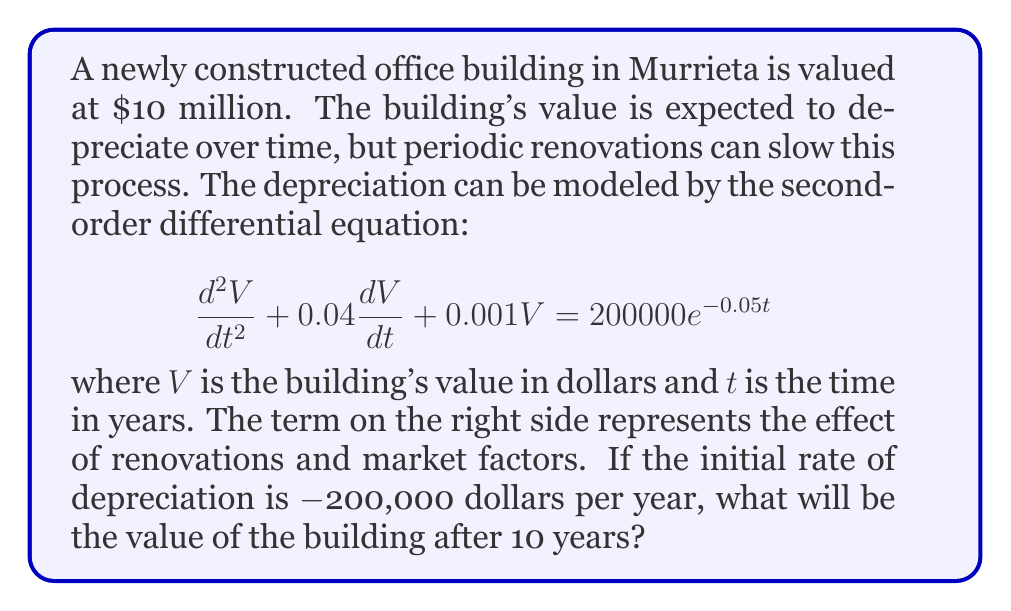Provide a solution to this math problem. To solve this problem, we need to follow these steps:

1) First, we need to identify the initial conditions:
   $V(0) = 10,000,000$ (initial value)
   $V'(0) = -200,000$ (initial rate of change)

2) The general solution to this differential equation is of the form:
   $V(t) = V_h(t) + V_p(t)$
   where $V_h(t)$ is the homogeneous solution and $V_p(t)$ is the particular solution.

3) The characteristic equation for the homogeneous part is:
   $r^2 + 0.04r + 0.001 = 0$
   Solving this gives us: $r_1 = -0.02 + 0.01i$ and $r_2 = -0.02 - 0.01i$

4) Therefore, the homogeneous solution is:
   $V_h(t) = e^{-0.02t}(C_1\cos(0.01t) + C_2\sin(0.01t))$

5) For the particular solution, we can guess a form:
   $V_p(t) = Ae^{-0.05t}$
   Substituting this into the original equation gives us:
   $A = 200,000,000$

6) So, the general solution is:
   $V(t) = e^{-0.02t}(C_1\cos(0.01t) + C_2\sin(0.01t)) + 200,000,000e^{-0.05t}$

7) Using the initial conditions, we can solve for $C_1$ and $C_2$:
   $C_1 = -190,000,000$
   $C_2 = -100,000,000$

8) Therefore, the specific solution is:
   $V(t) = e^{-0.02t}(-190,000,000\cos(0.01t) - 100,000,000\sin(0.01t)) + 200,000,000e^{-0.05t}$

9) To find the value after 10 years, we substitute $t = 10$:
   $V(10) \approx 8,187,308.62$
Answer: The value of the office building after 10 years will be approximately $8,187,309. 